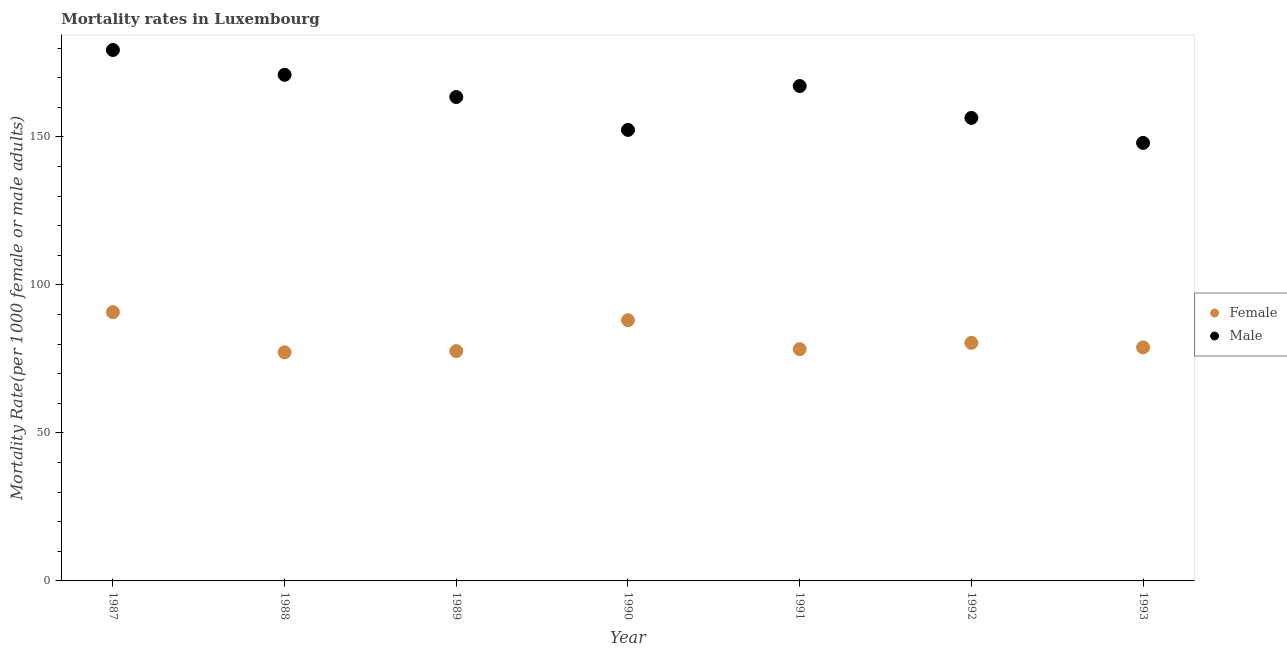What is the male mortality rate in 1993?
Provide a short and direct response. 147.97. Across all years, what is the maximum female mortality rate?
Provide a succinct answer. 90.79. Across all years, what is the minimum male mortality rate?
Ensure brevity in your answer.  147.97. In which year was the male mortality rate maximum?
Provide a short and direct response. 1987. In which year was the female mortality rate minimum?
Ensure brevity in your answer.  1988. What is the total female mortality rate in the graph?
Your answer should be very brief. 571.31. What is the difference between the female mortality rate in 1988 and that in 1990?
Offer a terse response. -10.84. What is the difference between the male mortality rate in 1989 and the female mortality rate in 1993?
Keep it short and to the point. 84.58. What is the average male mortality rate per year?
Your response must be concise. 162.53. In the year 1992, what is the difference between the female mortality rate and male mortality rate?
Provide a succinct answer. -75.99. In how many years, is the female mortality rate greater than 110?
Give a very brief answer. 0. What is the ratio of the female mortality rate in 1990 to that in 1993?
Your answer should be very brief. 1.12. Is the male mortality rate in 1987 less than that in 1991?
Make the answer very short. No. Is the difference between the male mortality rate in 1987 and 1993 greater than the difference between the female mortality rate in 1987 and 1993?
Ensure brevity in your answer.  Yes. What is the difference between the highest and the second highest female mortality rate?
Offer a very short reply. 2.73. What is the difference between the highest and the lowest female mortality rate?
Keep it short and to the point. 13.57. Does the female mortality rate monotonically increase over the years?
Keep it short and to the point. No. Is the male mortality rate strictly greater than the female mortality rate over the years?
Offer a terse response. Yes. How many dotlines are there?
Make the answer very short. 2. How many years are there in the graph?
Provide a succinct answer. 7. Are the values on the major ticks of Y-axis written in scientific E-notation?
Your answer should be very brief. No. How many legend labels are there?
Offer a terse response. 2. What is the title of the graph?
Ensure brevity in your answer.  Mortality rates in Luxembourg. Does "Electricity" appear as one of the legend labels in the graph?
Your response must be concise. No. What is the label or title of the Y-axis?
Give a very brief answer. Mortality Rate(per 1000 female or male adults). What is the Mortality Rate(per 1000 female or male adults) in Female in 1987?
Provide a short and direct response. 90.79. What is the Mortality Rate(per 1000 female or male adults) in Male in 1987?
Offer a terse response. 179.35. What is the Mortality Rate(per 1000 female or male adults) in Female in 1988?
Make the answer very short. 77.22. What is the Mortality Rate(per 1000 female or male adults) of Male in 1988?
Give a very brief answer. 170.97. What is the Mortality Rate(per 1000 female or male adults) in Female in 1989?
Provide a short and direct response. 77.63. What is the Mortality Rate(per 1000 female or male adults) in Male in 1989?
Offer a very short reply. 163.47. What is the Mortality Rate(per 1000 female or male adults) of Female in 1990?
Your response must be concise. 88.06. What is the Mortality Rate(per 1000 female or male adults) in Male in 1990?
Ensure brevity in your answer.  152.36. What is the Mortality Rate(per 1000 female or male adults) of Female in 1991?
Give a very brief answer. 78.29. What is the Mortality Rate(per 1000 female or male adults) in Male in 1991?
Provide a succinct answer. 167.18. What is the Mortality Rate(per 1000 female or male adults) of Female in 1992?
Your response must be concise. 80.42. What is the Mortality Rate(per 1000 female or male adults) in Male in 1992?
Make the answer very short. 156.41. What is the Mortality Rate(per 1000 female or male adults) of Female in 1993?
Your answer should be very brief. 78.89. What is the Mortality Rate(per 1000 female or male adults) of Male in 1993?
Provide a short and direct response. 147.97. Across all years, what is the maximum Mortality Rate(per 1000 female or male adults) of Female?
Offer a terse response. 90.79. Across all years, what is the maximum Mortality Rate(per 1000 female or male adults) of Male?
Keep it short and to the point. 179.35. Across all years, what is the minimum Mortality Rate(per 1000 female or male adults) in Female?
Your answer should be compact. 77.22. Across all years, what is the minimum Mortality Rate(per 1000 female or male adults) in Male?
Your answer should be very brief. 147.97. What is the total Mortality Rate(per 1000 female or male adults) of Female in the graph?
Make the answer very short. 571.31. What is the total Mortality Rate(per 1000 female or male adults) in Male in the graph?
Offer a terse response. 1137.71. What is the difference between the Mortality Rate(per 1000 female or male adults) of Female in 1987 and that in 1988?
Your answer should be very brief. 13.57. What is the difference between the Mortality Rate(per 1000 female or male adults) of Male in 1987 and that in 1988?
Your response must be concise. 8.38. What is the difference between the Mortality Rate(per 1000 female or male adults) of Female in 1987 and that in 1989?
Your answer should be compact. 13.16. What is the difference between the Mortality Rate(per 1000 female or male adults) in Male in 1987 and that in 1989?
Keep it short and to the point. 15.89. What is the difference between the Mortality Rate(per 1000 female or male adults) in Female in 1987 and that in 1990?
Offer a terse response. 2.73. What is the difference between the Mortality Rate(per 1000 female or male adults) in Male in 1987 and that in 1990?
Provide a short and direct response. 27. What is the difference between the Mortality Rate(per 1000 female or male adults) in Female in 1987 and that in 1991?
Offer a very short reply. 12.5. What is the difference between the Mortality Rate(per 1000 female or male adults) of Male in 1987 and that in 1991?
Your answer should be very brief. 12.18. What is the difference between the Mortality Rate(per 1000 female or male adults) of Female in 1987 and that in 1992?
Your answer should be compact. 10.37. What is the difference between the Mortality Rate(per 1000 female or male adults) in Male in 1987 and that in 1992?
Give a very brief answer. 22.94. What is the difference between the Mortality Rate(per 1000 female or male adults) of Female in 1987 and that in 1993?
Your answer should be compact. 11.91. What is the difference between the Mortality Rate(per 1000 female or male adults) of Male in 1987 and that in 1993?
Give a very brief answer. 31.39. What is the difference between the Mortality Rate(per 1000 female or male adults) of Female in 1988 and that in 1989?
Provide a succinct answer. -0.41. What is the difference between the Mortality Rate(per 1000 female or male adults) of Male in 1988 and that in 1989?
Your answer should be very brief. 7.51. What is the difference between the Mortality Rate(per 1000 female or male adults) in Female in 1988 and that in 1990?
Offer a very short reply. -10.84. What is the difference between the Mortality Rate(per 1000 female or male adults) in Male in 1988 and that in 1990?
Your answer should be compact. 18.62. What is the difference between the Mortality Rate(per 1000 female or male adults) in Female in 1988 and that in 1991?
Offer a very short reply. -1.07. What is the difference between the Mortality Rate(per 1000 female or male adults) in Male in 1988 and that in 1991?
Offer a very short reply. 3.79. What is the difference between the Mortality Rate(per 1000 female or male adults) of Female in 1988 and that in 1992?
Your response must be concise. -3.2. What is the difference between the Mortality Rate(per 1000 female or male adults) of Male in 1988 and that in 1992?
Your answer should be compact. 14.56. What is the difference between the Mortality Rate(per 1000 female or male adults) of Female in 1988 and that in 1993?
Offer a terse response. -1.66. What is the difference between the Mortality Rate(per 1000 female or male adults) of Male in 1988 and that in 1993?
Keep it short and to the point. 23. What is the difference between the Mortality Rate(per 1000 female or male adults) of Female in 1989 and that in 1990?
Make the answer very short. -10.43. What is the difference between the Mortality Rate(per 1000 female or male adults) of Male in 1989 and that in 1990?
Provide a succinct answer. 11.11. What is the difference between the Mortality Rate(per 1000 female or male adults) in Female in 1989 and that in 1991?
Keep it short and to the point. -0.66. What is the difference between the Mortality Rate(per 1000 female or male adults) in Male in 1989 and that in 1991?
Make the answer very short. -3.71. What is the difference between the Mortality Rate(per 1000 female or male adults) of Female in 1989 and that in 1992?
Ensure brevity in your answer.  -2.79. What is the difference between the Mortality Rate(per 1000 female or male adults) in Male in 1989 and that in 1992?
Offer a very short reply. 7.05. What is the difference between the Mortality Rate(per 1000 female or male adults) in Female in 1989 and that in 1993?
Your answer should be very brief. -1.25. What is the difference between the Mortality Rate(per 1000 female or male adults) of Male in 1989 and that in 1993?
Your answer should be very brief. 15.5. What is the difference between the Mortality Rate(per 1000 female or male adults) in Female in 1990 and that in 1991?
Ensure brevity in your answer.  9.77. What is the difference between the Mortality Rate(per 1000 female or male adults) of Male in 1990 and that in 1991?
Keep it short and to the point. -14.82. What is the difference between the Mortality Rate(per 1000 female or male adults) in Female in 1990 and that in 1992?
Your response must be concise. 7.64. What is the difference between the Mortality Rate(per 1000 female or male adults) of Male in 1990 and that in 1992?
Offer a terse response. -4.06. What is the difference between the Mortality Rate(per 1000 female or male adults) in Female in 1990 and that in 1993?
Provide a short and direct response. 9.18. What is the difference between the Mortality Rate(per 1000 female or male adults) in Male in 1990 and that in 1993?
Your answer should be very brief. 4.39. What is the difference between the Mortality Rate(per 1000 female or male adults) of Female in 1991 and that in 1992?
Offer a terse response. -2.13. What is the difference between the Mortality Rate(per 1000 female or male adults) of Male in 1991 and that in 1992?
Provide a succinct answer. 10.76. What is the difference between the Mortality Rate(per 1000 female or male adults) of Female in 1991 and that in 1993?
Keep it short and to the point. -0.59. What is the difference between the Mortality Rate(per 1000 female or male adults) in Male in 1991 and that in 1993?
Your answer should be very brief. 19.21. What is the difference between the Mortality Rate(per 1000 female or male adults) of Female in 1992 and that in 1993?
Your response must be concise. 1.54. What is the difference between the Mortality Rate(per 1000 female or male adults) in Male in 1992 and that in 1993?
Your response must be concise. 8.45. What is the difference between the Mortality Rate(per 1000 female or male adults) of Female in 1987 and the Mortality Rate(per 1000 female or male adults) of Male in 1988?
Make the answer very short. -80.18. What is the difference between the Mortality Rate(per 1000 female or male adults) of Female in 1987 and the Mortality Rate(per 1000 female or male adults) of Male in 1989?
Your answer should be very brief. -72.67. What is the difference between the Mortality Rate(per 1000 female or male adults) in Female in 1987 and the Mortality Rate(per 1000 female or male adults) in Male in 1990?
Offer a very short reply. -61.56. What is the difference between the Mortality Rate(per 1000 female or male adults) in Female in 1987 and the Mortality Rate(per 1000 female or male adults) in Male in 1991?
Your answer should be very brief. -76.39. What is the difference between the Mortality Rate(per 1000 female or male adults) in Female in 1987 and the Mortality Rate(per 1000 female or male adults) in Male in 1992?
Provide a short and direct response. -65.62. What is the difference between the Mortality Rate(per 1000 female or male adults) in Female in 1987 and the Mortality Rate(per 1000 female or male adults) in Male in 1993?
Provide a short and direct response. -57.17. What is the difference between the Mortality Rate(per 1000 female or male adults) of Female in 1988 and the Mortality Rate(per 1000 female or male adults) of Male in 1989?
Give a very brief answer. -86.24. What is the difference between the Mortality Rate(per 1000 female or male adults) of Female in 1988 and the Mortality Rate(per 1000 female or male adults) of Male in 1990?
Make the answer very short. -75.13. What is the difference between the Mortality Rate(per 1000 female or male adults) of Female in 1988 and the Mortality Rate(per 1000 female or male adults) of Male in 1991?
Provide a succinct answer. -89.96. What is the difference between the Mortality Rate(per 1000 female or male adults) in Female in 1988 and the Mortality Rate(per 1000 female or male adults) in Male in 1992?
Your answer should be compact. -79.19. What is the difference between the Mortality Rate(per 1000 female or male adults) of Female in 1988 and the Mortality Rate(per 1000 female or male adults) of Male in 1993?
Provide a succinct answer. -70.75. What is the difference between the Mortality Rate(per 1000 female or male adults) in Female in 1989 and the Mortality Rate(per 1000 female or male adults) in Male in 1990?
Offer a terse response. -74.72. What is the difference between the Mortality Rate(per 1000 female or male adults) in Female in 1989 and the Mortality Rate(per 1000 female or male adults) in Male in 1991?
Give a very brief answer. -89.55. What is the difference between the Mortality Rate(per 1000 female or male adults) of Female in 1989 and the Mortality Rate(per 1000 female or male adults) of Male in 1992?
Your answer should be very brief. -78.78. What is the difference between the Mortality Rate(per 1000 female or male adults) in Female in 1989 and the Mortality Rate(per 1000 female or male adults) in Male in 1993?
Give a very brief answer. -70.33. What is the difference between the Mortality Rate(per 1000 female or male adults) in Female in 1990 and the Mortality Rate(per 1000 female or male adults) in Male in 1991?
Keep it short and to the point. -79.12. What is the difference between the Mortality Rate(per 1000 female or male adults) of Female in 1990 and the Mortality Rate(per 1000 female or male adults) of Male in 1992?
Provide a short and direct response. -68.35. What is the difference between the Mortality Rate(per 1000 female or male adults) in Female in 1990 and the Mortality Rate(per 1000 female or male adults) in Male in 1993?
Provide a succinct answer. -59.91. What is the difference between the Mortality Rate(per 1000 female or male adults) in Female in 1991 and the Mortality Rate(per 1000 female or male adults) in Male in 1992?
Your response must be concise. -78.12. What is the difference between the Mortality Rate(per 1000 female or male adults) in Female in 1991 and the Mortality Rate(per 1000 female or male adults) in Male in 1993?
Provide a short and direct response. -69.67. What is the difference between the Mortality Rate(per 1000 female or male adults) in Female in 1992 and the Mortality Rate(per 1000 female or male adults) in Male in 1993?
Your answer should be compact. -67.54. What is the average Mortality Rate(per 1000 female or male adults) of Female per year?
Your answer should be very brief. 81.62. What is the average Mortality Rate(per 1000 female or male adults) in Male per year?
Keep it short and to the point. 162.53. In the year 1987, what is the difference between the Mortality Rate(per 1000 female or male adults) in Female and Mortality Rate(per 1000 female or male adults) in Male?
Provide a succinct answer. -88.56. In the year 1988, what is the difference between the Mortality Rate(per 1000 female or male adults) of Female and Mortality Rate(per 1000 female or male adults) of Male?
Make the answer very short. -93.75. In the year 1989, what is the difference between the Mortality Rate(per 1000 female or male adults) of Female and Mortality Rate(per 1000 female or male adults) of Male?
Keep it short and to the point. -85.83. In the year 1990, what is the difference between the Mortality Rate(per 1000 female or male adults) of Female and Mortality Rate(per 1000 female or male adults) of Male?
Offer a very short reply. -64.3. In the year 1991, what is the difference between the Mortality Rate(per 1000 female or male adults) in Female and Mortality Rate(per 1000 female or male adults) in Male?
Offer a very short reply. -88.89. In the year 1992, what is the difference between the Mortality Rate(per 1000 female or male adults) of Female and Mortality Rate(per 1000 female or male adults) of Male?
Your answer should be compact. -75.99. In the year 1993, what is the difference between the Mortality Rate(per 1000 female or male adults) of Female and Mortality Rate(per 1000 female or male adults) of Male?
Your response must be concise. -69.08. What is the ratio of the Mortality Rate(per 1000 female or male adults) in Female in 1987 to that in 1988?
Offer a terse response. 1.18. What is the ratio of the Mortality Rate(per 1000 female or male adults) of Male in 1987 to that in 1988?
Keep it short and to the point. 1.05. What is the ratio of the Mortality Rate(per 1000 female or male adults) of Female in 1987 to that in 1989?
Your answer should be compact. 1.17. What is the ratio of the Mortality Rate(per 1000 female or male adults) in Male in 1987 to that in 1989?
Provide a short and direct response. 1.1. What is the ratio of the Mortality Rate(per 1000 female or male adults) of Female in 1987 to that in 1990?
Provide a succinct answer. 1.03. What is the ratio of the Mortality Rate(per 1000 female or male adults) of Male in 1987 to that in 1990?
Your answer should be compact. 1.18. What is the ratio of the Mortality Rate(per 1000 female or male adults) in Female in 1987 to that in 1991?
Offer a very short reply. 1.16. What is the ratio of the Mortality Rate(per 1000 female or male adults) in Male in 1987 to that in 1991?
Give a very brief answer. 1.07. What is the ratio of the Mortality Rate(per 1000 female or male adults) of Female in 1987 to that in 1992?
Offer a very short reply. 1.13. What is the ratio of the Mortality Rate(per 1000 female or male adults) of Male in 1987 to that in 1992?
Offer a terse response. 1.15. What is the ratio of the Mortality Rate(per 1000 female or male adults) of Female in 1987 to that in 1993?
Ensure brevity in your answer.  1.15. What is the ratio of the Mortality Rate(per 1000 female or male adults) in Male in 1987 to that in 1993?
Ensure brevity in your answer.  1.21. What is the ratio of the Mortality Rate(per 1000 female or male adults) of Male in 1988 to that in 1989?
Provide a short and direct response. 1.05. What is the ratio of the Mortality Rate(per 1000 female or male adults) of Female in 1988 to that in 1990?
Offer a very short reply. 0.88. What is the ratio of the Mortality Rate(per 1000 female or male adults) in Male in 1988 to that in 1990?
Offer a terse response. 1.12. What is the ratio of the Mortality Rate(per 1000 female or male adults) of Female in 1988 to that in 1991?
Your answer should be very brief. 0.99. What is the ratio of the Mortality Rate(per 1000 female or male adults) of Male in 1988 to that in 1991?
Make the answer very short. 1.02. What is the ratio of the Mortality Rate(per 1000 female or male adults) of Female in 1988 to that in 1992?
Offer a very short reply. 0.96. What is the ratio of the Mortality Rate(per 1000 female or male adults) of Male in 1988 to that in 1992?
Keep it short and to the point. 1.09. What is the ratio of the Mortality Rate(per 1000 female or male adults) of Female in 1988 to that in 1993?
Make the answer very short. 0.98. What is the ratio of the Mortality Rate(per 1000 female or male adults) of Male in 1988 to that in 1993?
Keep it short and to the point. 1.16. What is the ratio of the Mortality Rate(per 1000 female or male adults) of Female in 1989 to that in 1990?
Offer a terse response. 0.88. What is the ratio of the Mortality Rate(per 1000 female or male adults) of Male in 1989 to that in 1990?
Provide a succinct answer. 1.07. What is the ratio of the Mortality Rate(per 1000 female or male adults) of Male in 1989 to that in 1991?
Keep it short and to the point. 0.98. What is the ratio of the Mortality Rate(per 1000 female or male adults) of Female in 1989 to that in 1992?
Your answer should be compact. 0.97. What is the ratio of the Mortality Rate(per 1000 female or male adults) in Male in 1989 to that in 1992?
Offer a terse response. 1.05. What is the ratio of the Mortality Rate(per 1000 female or male adults) of Female in 1989 to that in 1993?
Provide a short and direct response. 0.98. What is the ratio of the Mortality Rate(per 1000 female or male adults) of Male in 1989 to that in 1993?
Offer a very short reply. 1.1. What is the ratio of the Mortality Rate(per 1000 female or male adults) in Female in 1990 to that in 1991?
Ensure brevity in your answer.  1.12. What is the ratio of the Mortality Rate(per 1000 female or male adults) of Male in 1990 to that in 1991?
Your answer should be very brief. 0.91. What is the ratio of the Mortality Rate(per 1000 female or male adults) of Female in 1990 to that in 1992?
Provide a short and direct response. 1.09. What is the ratio of the Mortality Rate(per 1000 female or male adults) of Male in 1990 to that in 1992?
Offer a terse response. 0.97. What is the ratio of the Mortality Rate(per 1000 female or male adults) of Female in 1990 to that in 1993?
Make the answer very short. 1.12. What is the ratio of the Mortality Rate(per 1000 female or male adults) of Male in 1990 to that in 1993?
Ensure brevity in your answer.  1.03. What is the ratio of the Mortality Rate(per 1000 female or male adults) in Female in 1991 to that in 1992?
Make the answer very short. 0.97. What is the ratio of the Mortality Rate(per 1000 female or male adults) in Male in 1991 to that in 1992?
Your answer should be very brief. 1.07. What is the ratio of the Mortality Rate(per 1000 female or male adults) of Female in 1991 to that in 1993?
Keep it short and to the point. 0.99. What is the ratio of the Mortality Rate(per 1000 female or male adults) of Male in 1991 to that in 1993?
Provide a succinct answer. 1.13. What is the ratio of the Mortality Rate(per 1000 female or male adults) in Female in 1992 to that in 1993?
Make the answer very short. 1.02. What is the ratio of the Mortality Rate(per 1000 female or male adults) of Male in 1992 to that in 1993?
Provide a short and direct response. 1.06. What is the difference between the highest and the second highest Mortality Rate(per 1000 female or male adults) in Female?
Offer a terse response. 2.73. What is the difference between the highest and the second highest Mortality Rate(per 1000 female or male adults) of Male?
Keep it short and to the point. 8.38. What is the difference between the highest and the lowest Mortality Rate(per 1000 female or male adults) in Female?
Provide a succinct answer. 13.57. What is the difference between the highest and the lowest Mortality Rate(per 1000 female or male adults) in Male?
Provide a succinct answer. 31.39. 